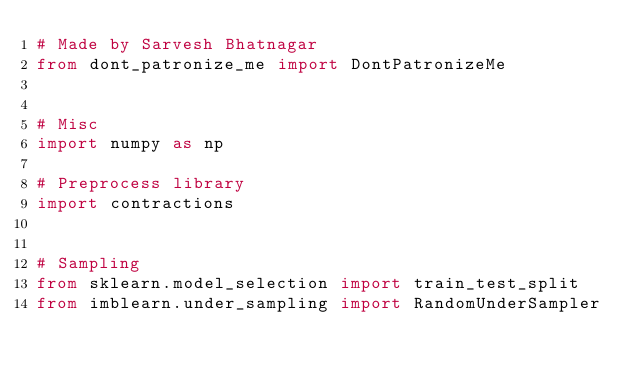Convert code to text. <code><loc_0><loc_0><loc_500><loc_500><_Python_># Made by Sarvesh Bhatnagar
from dont_patronize_me import DontPatronizeMe


# Misc
import numpy as np

# Preprocess library
import contractions


# Sampling
from sklearn.model_selection import train_test_split
from imblearn.under_sampling import RandomUnderSampler</code> 